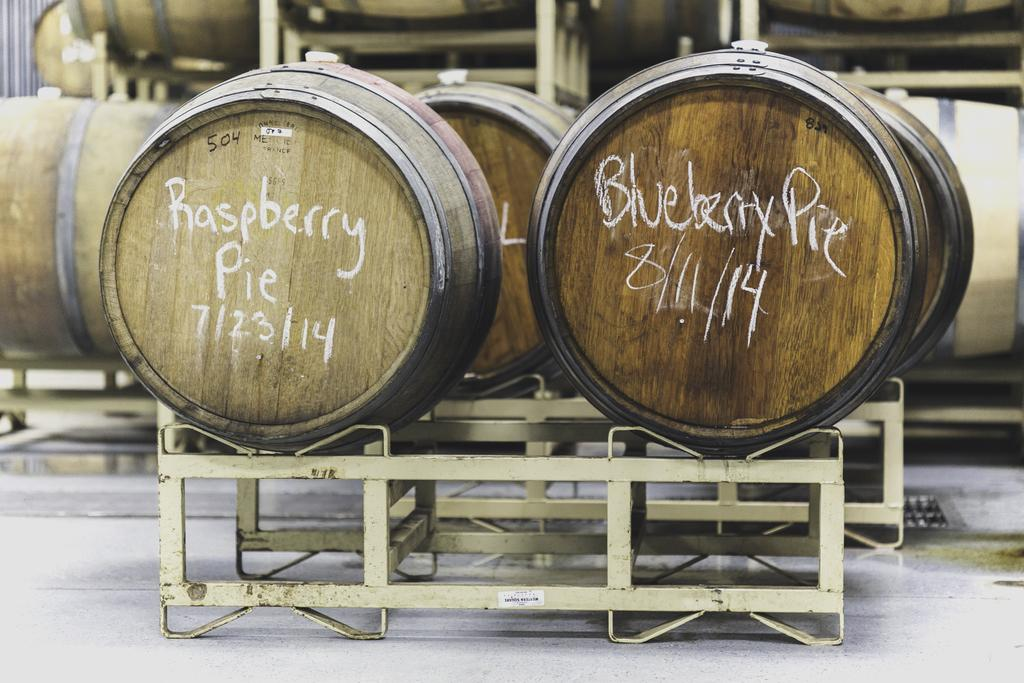What objects are present in the image? There are barrels in the image. How many toes can be seen on the barrels in the image? Barrels do not have toes, as they are inanimate objects. 